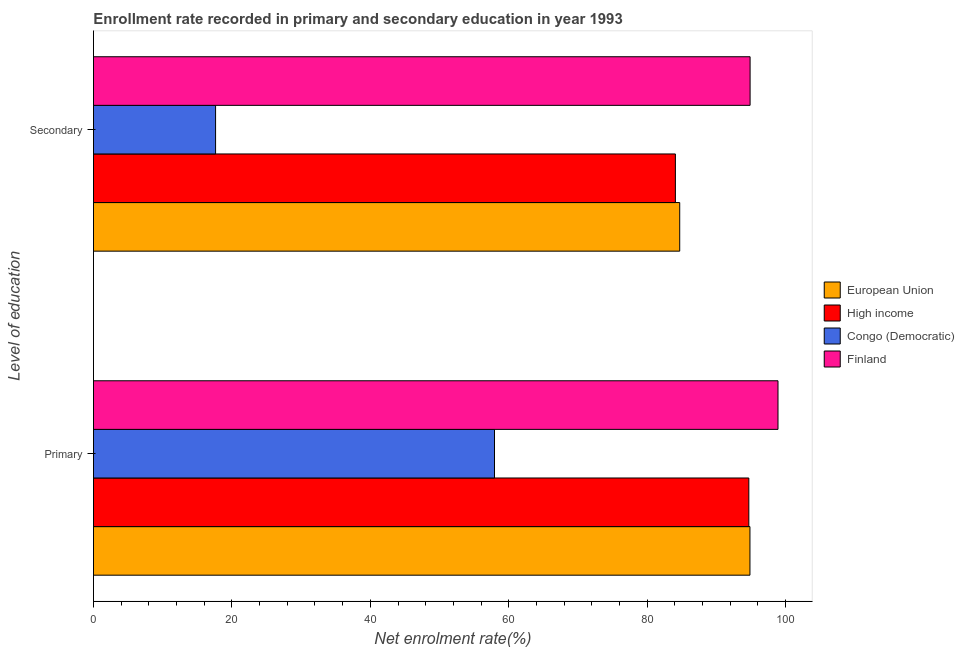Are the number of bars on each tick of the Y-axis equal?
Offer a terse response. Yes. What is the label of the 2nd group of bars from the top?
Offer a very short reply. Primary. What is the enrollment rate in primary education in European Union?
Provide a succinct answer. 94.84. Across all countries, what is the maximum enrollment rate in secondary education?
Make the answer very short. 94.86. Across all countries, what is the minimum enrollment rate in secondary education?
Provide a succinct answer. 17.64. In which country was the enrollment rate in secondary education minimum?
Offer a very short reply. Congo (Democratic). What is the total enrollment rate in secondary education in the graph?
Your response must be concise. 281.27. What is the difference between the enrollment rate in primary education in European Union and that in High income?
Provide a succinct answer. 0.16. What is the difference between the enrollment rate in secondary education in Finland and the enrollment rate in primary education in Congo (Democratic)?
Offer a terse response. 36.93. What is the average enrollment rate in secondary education per country?
Your response must be concise. 70.32. What is the difference between the enrollment rate in primary education and enrollment rate in secondary education in High income?
Offer a terse response. 10.61. In how many countries, is the enrollment rate in primary education greater than 24 %?
Your answer should be very brief. 4. What is the ratio of the enrollment rate in primary education in Finland to that in European Union?
Make the answer very short. 1.04. Is the enrollment rate in primary education in High income less than that in Congo (Democratic)?
Your answer should be compact. No. In how many countries, is the enrollment rate in primary education greater than the average enrollment rate in primary education taken over all countries?
Provide a succinct answer. 3. What does the 1st bar from the bottom in Primary represents?
Your response must be concise. European Union. How many countries are there in the graph?
Offer a terse response. 4. Does the graph contain any zero values?
Your response must be concise. No. Does the graph contain grids?
Keep it short and to the point. No. What is the title of the graph?
Your response must be concise. Enrollment rate recorded in primary and secondary education in year 1993. What is the label or title of the X-axis?
Offer a terse response. Net enrolment rate(%). What is the label or title of the Y-axis?
Keep it short and to the point. Level of education. What is the Net enrolment rate(%) in European Union in Primary?
Make the answer very short. 94.84. What is the Net enrolment rate(%) in High income in Primary?
Ensure brevity in your answer.  94.68. What is the Net enrolment rate(%) in Congo (Democratic) in Primary?
Your response must be concise. 57.94. What is the Net enrolment rate(%) of Finland in Primary?
Ensure brevity in your answer.  98.9. What is the Net enrolment rate(%) of European Union in Secondary?
Keep it short and to the point. 84.7. What is the Net enrolment rate(%) of High income in Secondary?
Offer a very short reply. 84.07. What is the Net enrolment rate(%) in Congo (Democratic) in Secondary?
Give a very brief answer. 17.64. What is the Net enrolment rate(%) of Finland in Secondary?
Make the answer very short. 94.86. Across all Level of education, what is the maximum Net enrolment rate(%) in European Union?
Provide a succinct answer. 94.84. Across all Level of education, what is the maximum Net enrolment rate(%) of High income?
Your response must be concise. 94.68. Across all Level of education, what is the maximum Net enrolment rate(%) of Congo (Democratic)?
Keep it short and to the point. 57.94. Across all Level of education, what is the maximum Net enrolment rate(%) in Finland?
Your response must be concise. 98.9. Across all Level of education, what is the minimum Net enrolment rate(%) of European Union?
Offer a terse response. 84.7. Across all Level of education, what is the minimum Net enrolment rate(%) of High income?
Provide a succinct answer. 84.07. Across all Level of education, what is the minimum Net enrolment rate(%) in Congo (Democratic)?
Offer a terse response. 17.64. Across all Level of education, what is the minimum Net enrolment rate(%) in Finland?
Ensure brevity in your answer.  94.86. What is the total Net enrolment rate(%) of European Union in the graph?
Make the answer very short. 179.54. What is the total Net enrolment rate(%) in High income in the graph?
Offer a very short reply. 178.75. What is the total Net enrolment rate(%) in Congo (Democratic) in the graph?
Provide a succinct answer. 75.58. What is the total Net enrolment rate(%) of Finland in the graph?
Ensure brevity in your answer.  193.76. What is the difference between the Net enrolment rate(%) of European Union in Primary and that in Secondary?
Provide a succinct answer. 10.15. What is the difference between the Net enrolment rate(%) in High income in Primary and that in Secondary?
Keep it short and to the point. 10.61. What is the difference between the Net enrolment rate(%) of Congo (Democratic) in Primary and that in Secondary?
Make the answer very short. 40.3. What is the difference between the Net enrolment rate(%) in Finland in Primary and that in Secondary?
Provide a succinct answer. 4.03. What is the difference between the Net enrolment rate(%) of European Union in Primary and the Net enrolment rate(%) of High income in Secondary?
Provide a short and direct response. 10.77. What is the difference between the Net enrolment rate(%) of European Union in Primary and the Net enrolment rate(%) of Congo (Democratic) in Secondary?
Provide a short and direct response. 77.2. What is the difference between the Net enrolment rate(%) in European Union in Primary and the Net enrolment rate(%) in Finland in Secondary?
Keep it short and to the point. -0.02. What is the difference between the Net enrolment rate(%) of High income in Primary and the Net enrolment rate(%) of Congo (Democratic) in Secondary?
Your answer should be compact. 77.04. What is the difference between the Net enrolment rate(%) of High income in Primary and the Net enrolment rate(%) of Finland in Secondary?
Your answer should be very brief. -0.18. What is the difference between the Net enrolment rate(%) of Congo (Democratic) in Primary and the Net enrolment rate(%) of Finland in Secondary?
Give a very brief answer. -36.93. What is the average Net enrolment rate(%) of European Union per Level of education?
Offer a very short reply. 89.77. What is the average Net enrolment rate(%) of High income per Level of education?
Your answer should be compact. 89.38. What is the average Net enrolment rate(%) in Congo (Democratic) per Level of education?
Provide a short and direct response. 37.79. What is the average Net enrolment rate(%) of Finland per Level of education?
Provide a short and direct response. 96.88. What is the difference between the Net enrolment rate(%) of European Union and Net enrolment rate(%) of High income in Primary?
Offer a very short reply. 0.16. What is the difference between the Net enrolment rate(%) in European Union and Net enrolment rate(%) in Congo (Democratic) in Primary?
Make the answer very short. 36.91. What is the difference between the Net enrolment rate(%) in European Union and Net enrolment rate(%) in Finland in Primary?
Keep it short and to the point. -4.05. What is the difference between the Net enrolment rate(%) in High income and Net enrolment rate(%) in Congo (Democratic) in Primary?
Ensure brevity in your answer.  36.74. What is the difference between the Net enrolment rate(%) in High income and Net enrolment rate(%) in Finland in Primary?
Provide a short and direct response. -4.21. What is the difference between the Net enrolment rate(%) of Congo (Democratic) and Net enrolment rate(%) of Finland in Primary?
Offer a very short reply. -40.96. What is the difference between the Net enrolment rate(%) of European Union and Net enrolment rate(%) of High income in Secondary?
Offer a very short reply. 0.63. What is the difference between the Net enrolment rate(%) in European Union and Net enrolment rate(%) in Congo (Democratic) in Secondary?
Your answer should be compact. 67.06. What is the difference between the Net enrolment rate(%) of European Union and Net enrolment rate(%) of Finland in Secondary?
Keep it short and to the point. -10.17. What is the difference between the Net enrolment rate(%) in High income and Net enrolment rate(%) in Congo (Democratic) in Secondary?
Your answer should be very brief. 66.43. What is the difference between the Net enrolment rate(%) in High income and Net enrolment rate(%) in Finland in Secondary?
Your answer should be compact. -10.79. What is the difference between the Net enrolment rate(%) of Congo (Democratic) and Net enrolment rate(%) of Finland in Secondary?
Your answer should be very brief. -77.22. What is the ratio of the Net enrolment rate(%) of European Union in Primary to that in Secondary?
Your answer should be compact. 1.12. What is the ratio of the Net enrolment rate(%) in High income in Primary to that in Secondary?
Offer a very short reply. 1.13. What is the ratio of the Net enrolment rate(%) of Congo (Democratic) in Primary to that in Secondary?
Provide a short and direct response. 3.28. What is the ratio of the Net enrolment rate(%) of Finland in Primary to that in Secondary?
Offer a terse response. 1.04. What is the difference between the highest and the second highest Net enrolment rate(%) of European Union?
Ensure brevity in your answer.  10.15. What is the difference between the highest and the second highest Net enrolment rate(%) in High income?
Provide a succinct answer. 10.61. What is the difference between the highest and the second highest Net enrolment rate(%) in Congo (Democratic)?
Provide a short and direct response. 40.3. What is the difference between the highest and the second highest Net enrolment rate(%) in Finland?
Your response must be concise. 4.03. What is the difference between the highest and the lowest Net enrolment rate(%) of European Union?
Make the answer very short. 10.15. What is the difference between the highest and the lowest Net enrolment rate(%) of High income?
Your answer should be compact. 10.61. What is the difference between the highest and the lowest Net enrolment rate(%) in Congo (Democratic)?
Give a very brief answer. 40.3. What is the difference between the highest and the lowest Net enrolment rate(%) in Finland?
Offer a terse response. 4.03. 